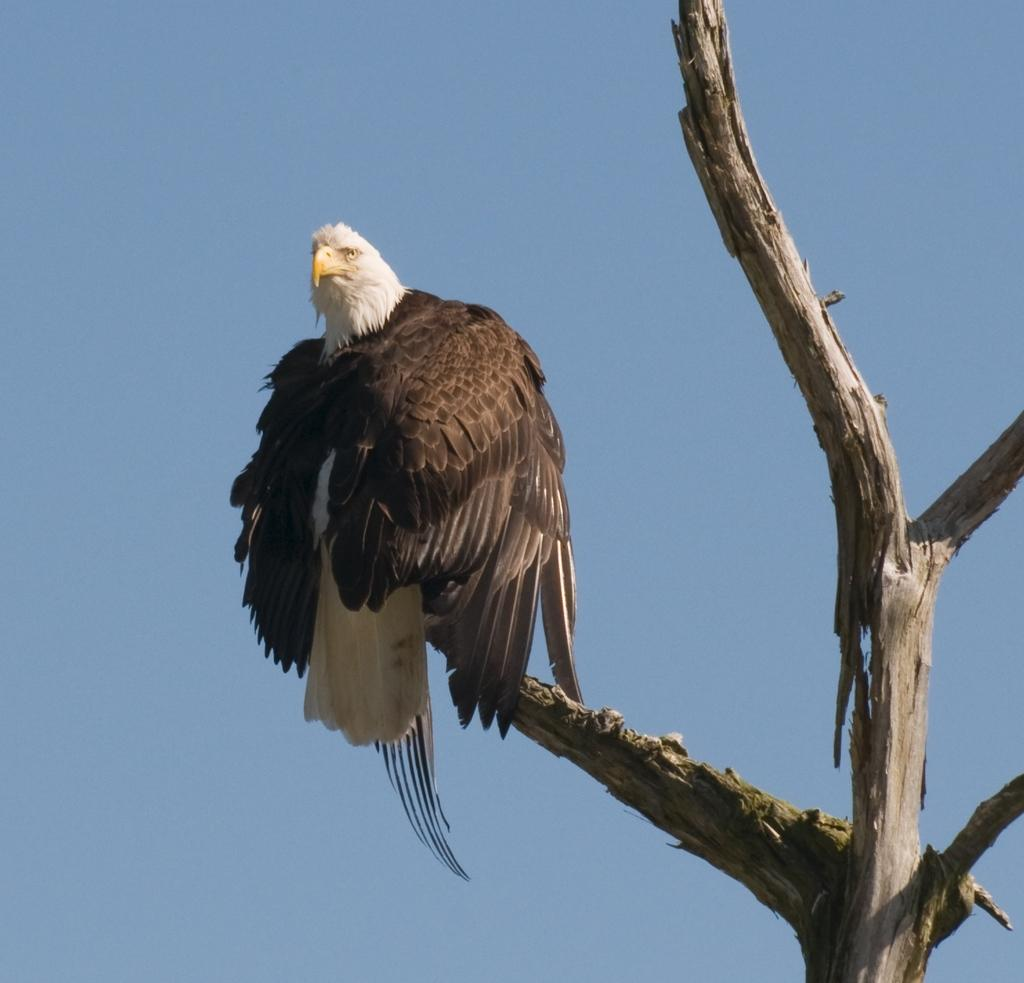What type of animal can be seen in the image? There is a bird in the image. Where is the bird located? The bird is on a wooden object. What other object can be seen in the image that resembles a dried tree? There is an object in the image that resembles a dried tree. What can be seen in the background of the image? The sky is visible in the background of the image. What guide is the bird using to navigate in the image? There is no guide present in the image, and the bird does not appear to be navigating. 